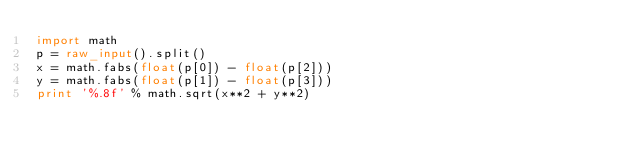Convert code to text. <code><loc_0><loc_0><loc_500><loc_500><_Python_>import math
p = raw_input().split()
x = math.fabs(float(p[0]) - float(p[2]))
y = math.fabs(float(p[1]) - float(p[3]))
print '%.8f' % math.sqrt(x**2 + y**2)</code> 